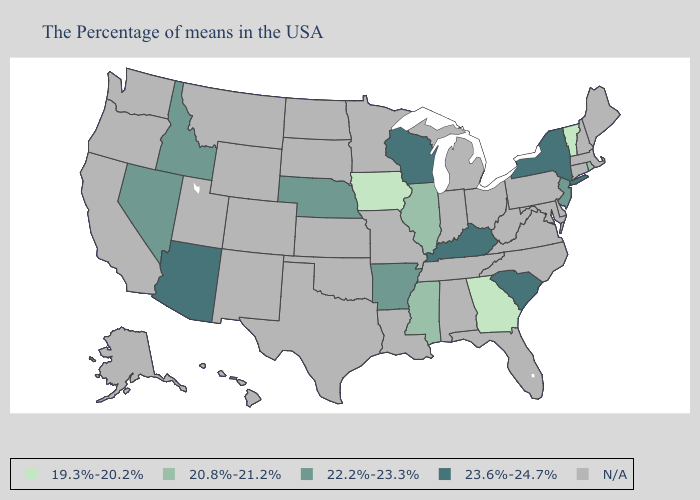What is the value of Rhode Island?
Keep it brief. 20.8%-21.2%. What is the lowest value in states that border South Carolina?
Quick response, please. 19.3%-20.2%. What is the highest value in the Northeast ?
Answer briefly. 23.6%-24.7%. What is the value of Texas?
Give a very brief answer. N/A. What is the highest value in the South ?
Be succinct. 23.6%-24.7%. Does Mississippi have the lowest value in the USA?
Answer briefly. No. What is the value of Idaho?
Answer briefly. 22.2%-23.3%. Name the states that have a value in the range 20.8%-21.2%?
Give a very brief answer. Rhode Island, Illinois, Mississippi. Name the states that have a value in the range N/A?
Quick response, please. Maine, Massachusetts, New Hampshire, Connecticut, Delaware, Maryland, Pennsylvania, Virginia, North Carolina, West Virginia, Ohio, Florida, Michigan, Indiana, Alabama, Tennessee, Louisiana, Missouri, Minnesota, Kansas, Oklahoma, Texas, South Dakota, North Dakota, Wyoming, Colorado, New Mexico, Utah, Montana, California, Washington, Oregon, Alaska, Hawaii. Name the states that have a value in the range 20.8%-21.2%?
Give a very brief answer. Rhode Island, Illinois, Mississippi. Does Georgia have the lowest value in the South?
Quick response, please. Yes. What is the value of New Hampshire?
Answer briefly. N/A. What is the highest value in states that border Utah?
Be succinct. 23.6%-24.7%. 